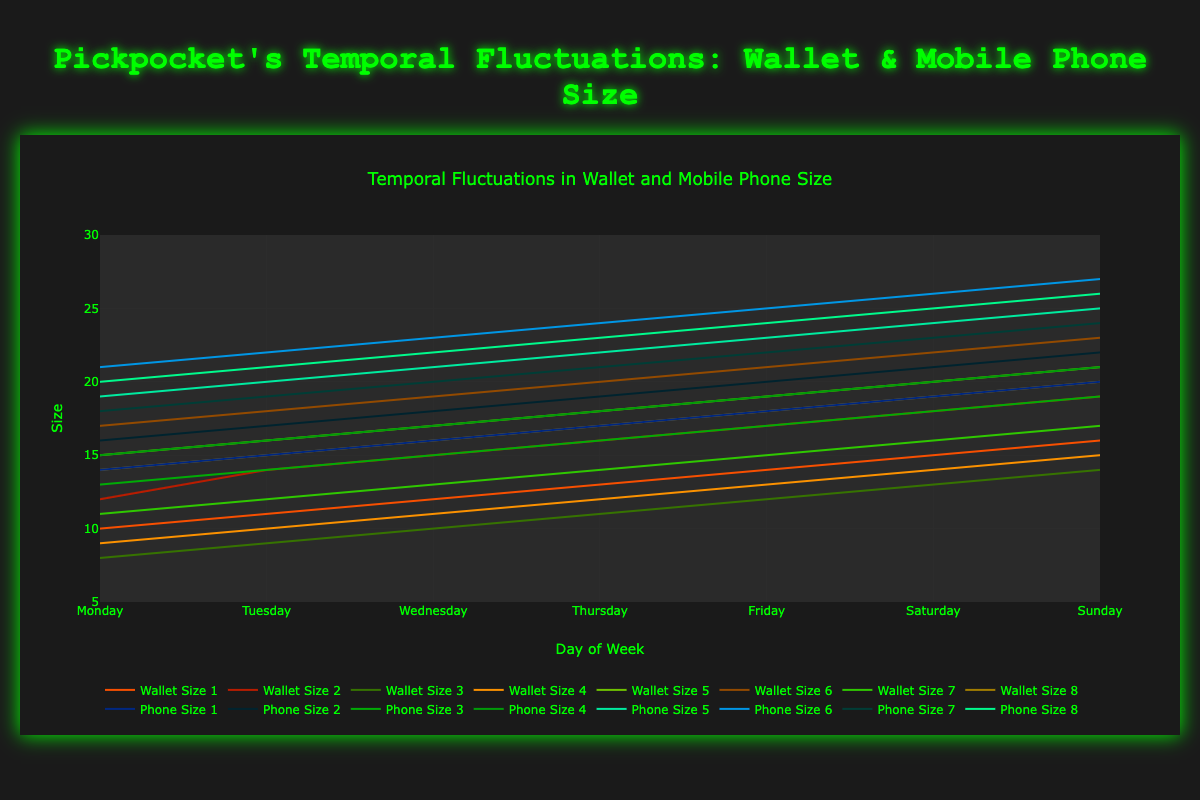How does the average wallet size on Sunday compare to the average wallet size on Monday? Calculate the average wallet size for both Sunday and Monday: Sunday: (16 + 19 + 14 + 15 + 21 + 23 + 17 + 20) / 8 = 18.125, Monday: (10 + 12 + 8 + 9 + 15 + 17 + 11 + 14) / 8 = 12
Answer: 18.125 is greater than 12 Which day shows the largest fluctuation in wallet sizes? Look for the greatest range in wallet sizes across the different days. Calculate the range by subtracting the smallest wallet size of the day from the largest. Sunday: 23 - 14 = 9, Monday: 17 - 8 = 9, Tuesday: 18 - 9 = 9, Wednesday: 19 - 10 = 9, Thursday: 20 - 11 = 9, Friday: 21 - 12 = 9, Saturday: 22 - 13 = 9. Since the fluctuation is the same all days, any day can be the answer
Answer: All days have the same fluctuation Which leads in terms of mobile phone size, Tuesday or Thursday? Compare the average mobile phone size for each of the days. Tuesday: (15 + 17 + 14 + 16 + 20 + 22 + 19 + 21) / 8 = 18, Thursday: (17 + 19 + 16 + 18 + 22 + 24 + 21 + 23) / 8 = 20
Answer: Thursday On which day is the difference between the largest wallet size and the smallest phone size smallest? Calculate the difference between the largest wallet size and the smallest phone size for each day: Monday: 17 - 13 = 4, Tuesday: 18 - 14 = 4, Wednesday: 19 - 15 = 4, Thursday: 20 - 16 = 4, Friday: 21 - 17 = 4, Saturday: 22 - 18 = 4, Sunday: 23 - 19 = 4
Answer: All days have the same difference If a pickpocket targets the largest mobile phone size every day of the week, what is the total size stolen at the end of the week? Sum up the largest mobile phone sizes for all days: Monday: 21, Tuesday: 22, Wednesday: 23, Thursday: 24, Friday: 25, Saturday: 26, Sunday: 27. Sum: 21 + 22 + 23 + 24 + 25 + 26 + 27 = 168
Answer: 168 Which days have wallet sizes that are consistently increasing through the week? Check the wallet sizes for consistency in increase: Monday to Sunday shows a steady increase: Monday: 17, Tuesday: 18, Wednesday: 19, Thursday: 20, Friday: 21, Saturday: 22, Sunday: 23
Answer: Monday to Sunday What is the average increase in mobile phone sizes from Saturday to Sunday for all values? Calculate the difference in mobile phone sizes between Saturday and Sunday, then average them: (20-19 + 22-21 + 19-18 + 21-20 + 25-24 + 27-26 + 24-23 + 26-25) / 8 = (1 + 1 + 1 + 1 + 1 + 1 + 1 + 1) / 8 = 1
Answer: 1 What is the correlation between wallet size and mobile phone size on Friday? Compare the pairs of wallet sizes and mobile phone sizes on Friday to find a pattern: Wallet: 14, 17, 12, 13, 19, 21, 15, 18. Mobile: 18, 20, 17, 19, 23, 25, 22, 24. The corresponding values increase together, showing positive correlation
Answer: Positive correlation 